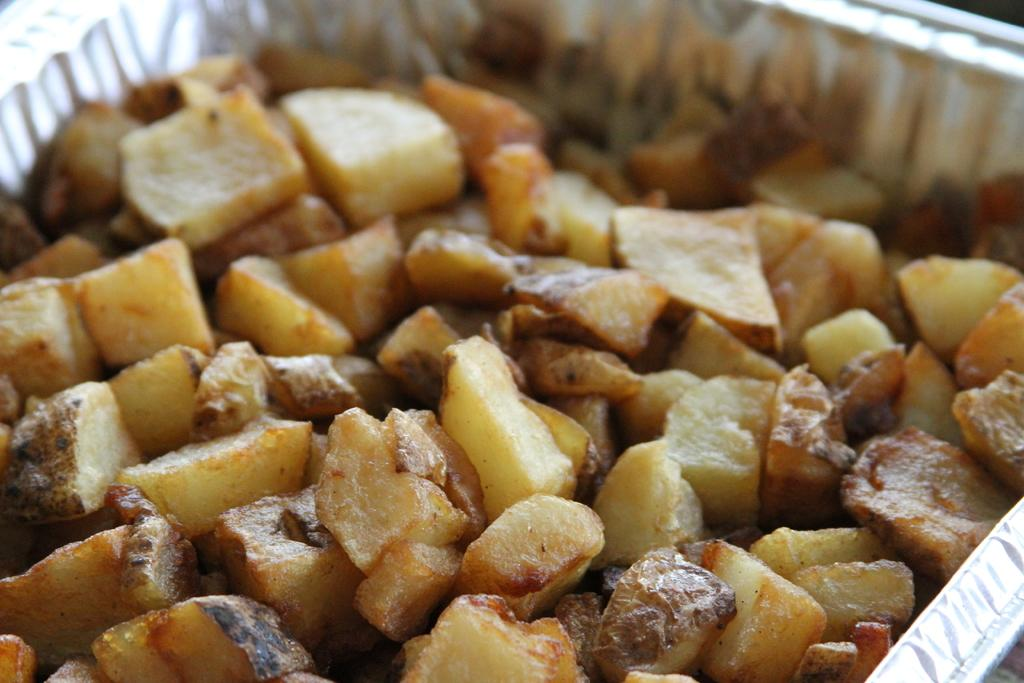What type of items can be seen in the image? There are eatables in the image. How are the eatables arranged or contained in the image? The eatables are placed in an object. What type of letter is visible in the image? There is no letter present in the image; it only contains eatables placed in an object. Can you see a basket in the image? The provided facts do not mention a basket, so we cannot determine if one is present in the image. 